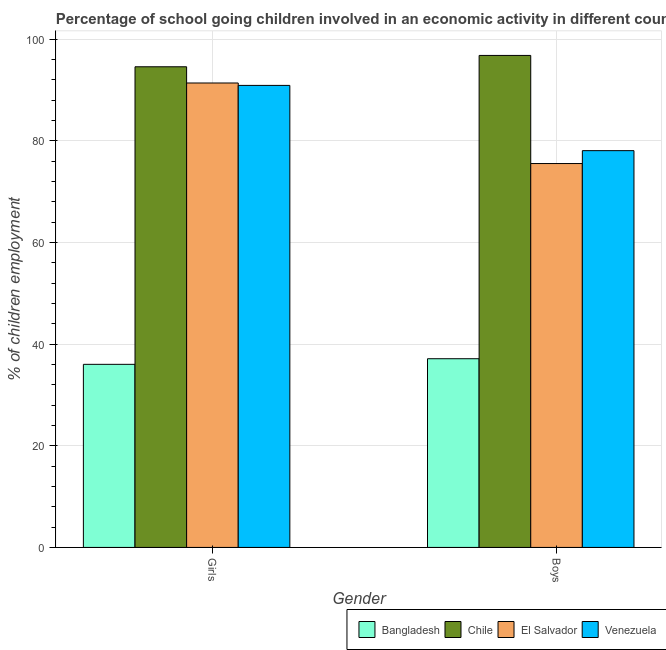How many different coloured bars are there?
Offer a very short reply. 4. How many groups of bars are there?
Offer a terse response. 2. Are the number of bars per tick equal to the number of legend labels?
Offer a terse response. Yes. How many bars are there on the 2nd tick from the right?
Make the answer very short. 4. What is the label of the 1st group of bars from the left?
Provide a short and direct response. Girls. What is the percentage of school going boys in Bangladesh?
Your answer should be compact. 37.13. Across all countries, what is the maximum percentage of school going boys?
Provide a short and direct response. 96.81. Across all countries, what is the minimum percentage of school going boys?
Provide a short and direct response. 37.13. In which country was the percentage of school going girls maximum?
Provide a short and direct response. Chile. In which country was the percentage of school going boys minimum?
Provide a short and direct response. Bangladesh. What is the total percentage of school going girls in the graph?
Your answer should be very brief. 312.89. What is the difference between the percentage of school going girls in Bangladesh and that in Venezuela?
Offer a very short reply. -54.88. What is the difference between the percentage of school going girls in Chile and the percentage of school going boys in El Salvador?
Offer a very short reply. 19.04. What is the average percentage of school going girls per country?
Offer a very short reply. 78.22. What is the difference between the percentage of school going girls and percentage of school going boys in El Salvador?
Offer a terse response. 15.85. What is the ratio of the percentage of school going girls in El Salvador to that in Venezuela?
Your answer should be very brief. 1.01. In how many countries, is the percentage of school going boys greater than the average percentage of school going boys taken over all countries?
Give a very brief answer. 3. What does the 4th bar from the left in Boys represents?
Make the answer very short. Venezuela. What does the 3rd bar from the right in Girls represents?
Offer a terse response. Chile. What is the difference between two consecutive major ticks on the Y-axis?
Ensure brevity in your answer.  20. Are the values on the major ticks of Y-axis written in scientific E-notation?
Give a very brief answer. No. How many legend labels are there?
Make the answer very short. 4. What is the title of the graph?
Make the answer very short. Percentage of school going children involved in an economic activity in different countries. What is the label or title of the Y-axis?
Offer a terse response. % of children employment. What is the % of children employment in Bangladesh in Girls?
Give a very brief answer. 36.02. What is the % of children employment of Chile in Girls?
Provide a short and direct response. 94.57. What is the % of children employment of El Salvador in Girls?
Keep it short and to the point. 91.38. What is the % of children employment in Venezuela in Girls?
Your response must be concise. 90.91. What is the % of children employment of Bangladesh in Boys?
Keep it short and to the point. 37.13. What is the % of children employment in Chile in Boys?
Keep it short and to the point. 96.81. What is the % of children employment of El Salvador in Boys?
Offer a terse response. 75.53. What is the % of children employment of Venezuela in Boys?
Make the answer very short. 78.07. Across all Gender, what is the maximum % of children employment in Bangladesh?
Provide a short and direct response. 37.13. Across all Gender, what is the maximum % of children employment of Chile?
Offer a very short reply. 96.81. Across all Gender, what is the maximum % of children employment of El Salvador?
Your answer should be very brief. 91.38. Across all Gender, what is the maximum % of children employment in Venezuela?
Offer a terse response. 90.91. Across all Gender, what is the minimum % of children employment of Bangladesh?
Ensure brevity in your answer.  36.02. Across all Gender, what is the minimum % of children employment in Chile?
Provide a short and direct response. 94.57. Across all Gender, what is the minimum % of children employment of El Salvador?
Your answer should be very brief. 75.53. Across all Gender, what is the minimum % of children employment in Venezuela?
Offer a terse response. 78.07. What is the total % of children employment in Bangladesh in the graph?
Make the answer very short. 73.15. What is the total % of children employment of Chile in the graph?
Offer a terse response. 191.38. What is the total % of children employment of El Salvador in the graph?
Your response must be concise. 166.92. What is the total % of children employment in Venezuela in the graph?
Your answer should be very brief. 168.98. What is the difference between the % of children employment of Bangladesh in Girls and that in Boys?
Provide a short and direct response. -1.11. What is the difference between the % of children employment in Chile in Girls and that in Boys?
Your answer should be compact. -2.23. What is the difference between the % of children employment in El Salvador in Girls and that in Boys?
Your answer should be very brief. 15.85. What is the difference between the % of children employment in Venezuela in Girls and that in Boys?
Your response must be concise. 12.84. What is the difference between the % of children employment in Bangladesh in Girls and the % of children employment in Chile in Boys?
Offer a terse response. -60.78. What is the difference between the % of children employment in Bangladesh in Girls and the % of children employment in El Salvador in Boys?
Make the answer very short. -39.51. What is the difference between the % of children employment of Bangladesh in Girls and the % of children employment of Venezuela in Boys?
Keep it short and to the point. -42.05. What is the difference between the % of children employment in Chile in Girls and the % of children employment in El Salvador in Boys?
Give a very brief answer. 19.04. What is the difference between the % of children employment of Chile in Girls and the % of children employment of Venezuela in Boys?
Offer a very short reply. 16.5. What is the difference between the % of children employment of El Salvador in Girls and the % of children employment of Venezuela in Boys?
Your answer should be compact. 13.31. What is the average % of children employment of Bangladesh per Gender?
Offer a terse response. 36.58. What is the average % of children employment of Chile per Gender?
Ensure brevity in your answer.  95.69. What is the average % of children employment in El Salvador per Gender?
Your response must be concise. 83.46. What is the average % of children employment of Venezuela per Gender?
Your response must be concise. 84.49. What is the difference between the % of children employment in Bangladesh and % of children employment in Chile in Girls?
Your response must be concise. -58.55. What is the difference between the % of children employment of Bangladesh and % of children employment of El Salvador in Girls?
Provide a short and direct response. -55.36. What is the difference between the % of children employment in Bangladesh and % of children employment in Venezuela in Girls?
Give a very brief answer. -54.88. What is the difference between the % of children employment of Chile and % of children employment of El Salvador in Girls?
Offer a terse response. 3.19. What is the difference between the % of children employment of Chile and % of children employment of Venezuela in Girls?
Ensure brevity in your answer.  3.67. What is the difference between the % of children employment in El Salvador and % of children employment in Venezuela in Girls?
Give a very brief answer. 0.47. What is the difference between the % of children employment in Bangladesh and % of children employment in Chile in Boys?
Give a very brief answer. -59.68. What is the difference between the % of children employment of Bangladesh and % of children employment of El Salvador in Boys?
Ensure brevity in your answer.  -38.4. What is the difference between the % of children employment of Bangladesh and % of children employment of Venezuela in Boys?
Ensure brevity in your answer.  -40.94. What is the difference between the % of children employment of Chile and % of children employment of El Salvador in Boys?
Ensure brevity in your answer.  21.27. What is the difference between the % of children employment in Chile and % of children employment in Venezuela in Boys?
Make the answer very short. 18.74. What is the difference between the % of children employment of El Salvador and % of children employment of Venezuela in Boys?
Keep it short and to the point. -2.54. What is the ratio of the % of children employment of Bangladesh in Girls to that in Boys?
Make the answer very short. 0.97. What is the ratio of the % of children employment in Chile in Girls to that in Boys?
Make the answer very short. 0.98. What is the ratio of the % of children employment of El Salvador in Girls to that in Boys?
Give a very brief answer. 1.21. What is the ratio of the % of children employment of Venezuela in Girls to that in Boys?
Provide a succinct answer. 1.16. What is the difference between the highest and the second highest % of children employment of Bangladesh?
Keep it short and to the point. 1.11. What is the difference between the highest and the second highest % of children employment of Chile?
Give a very brief answer. 2.23. What is the difference between the highest and the second highest % of children employment in El Salvador?
Keep it short and to the point. 15.85. What is the difference between the highest and the second highest % of children employment of Venezuela?
Ensure brevity in your answer.  12.84. What is the difference between the highest and the lowest % of children employment in Bangladesh?
Ensure brevity in your answer.  1.11. What is the difference between the highest and the lowest % of children employment in Chile?
Give a very brief answer. 2.23. What is the difference between the highest and the lowest % of children employment of El Salvador?
Make the answer very short. 15.85. What is the difference between the highest and the lowest % of children employment in Venezuela?
Offer a very short reply. 12.84. 